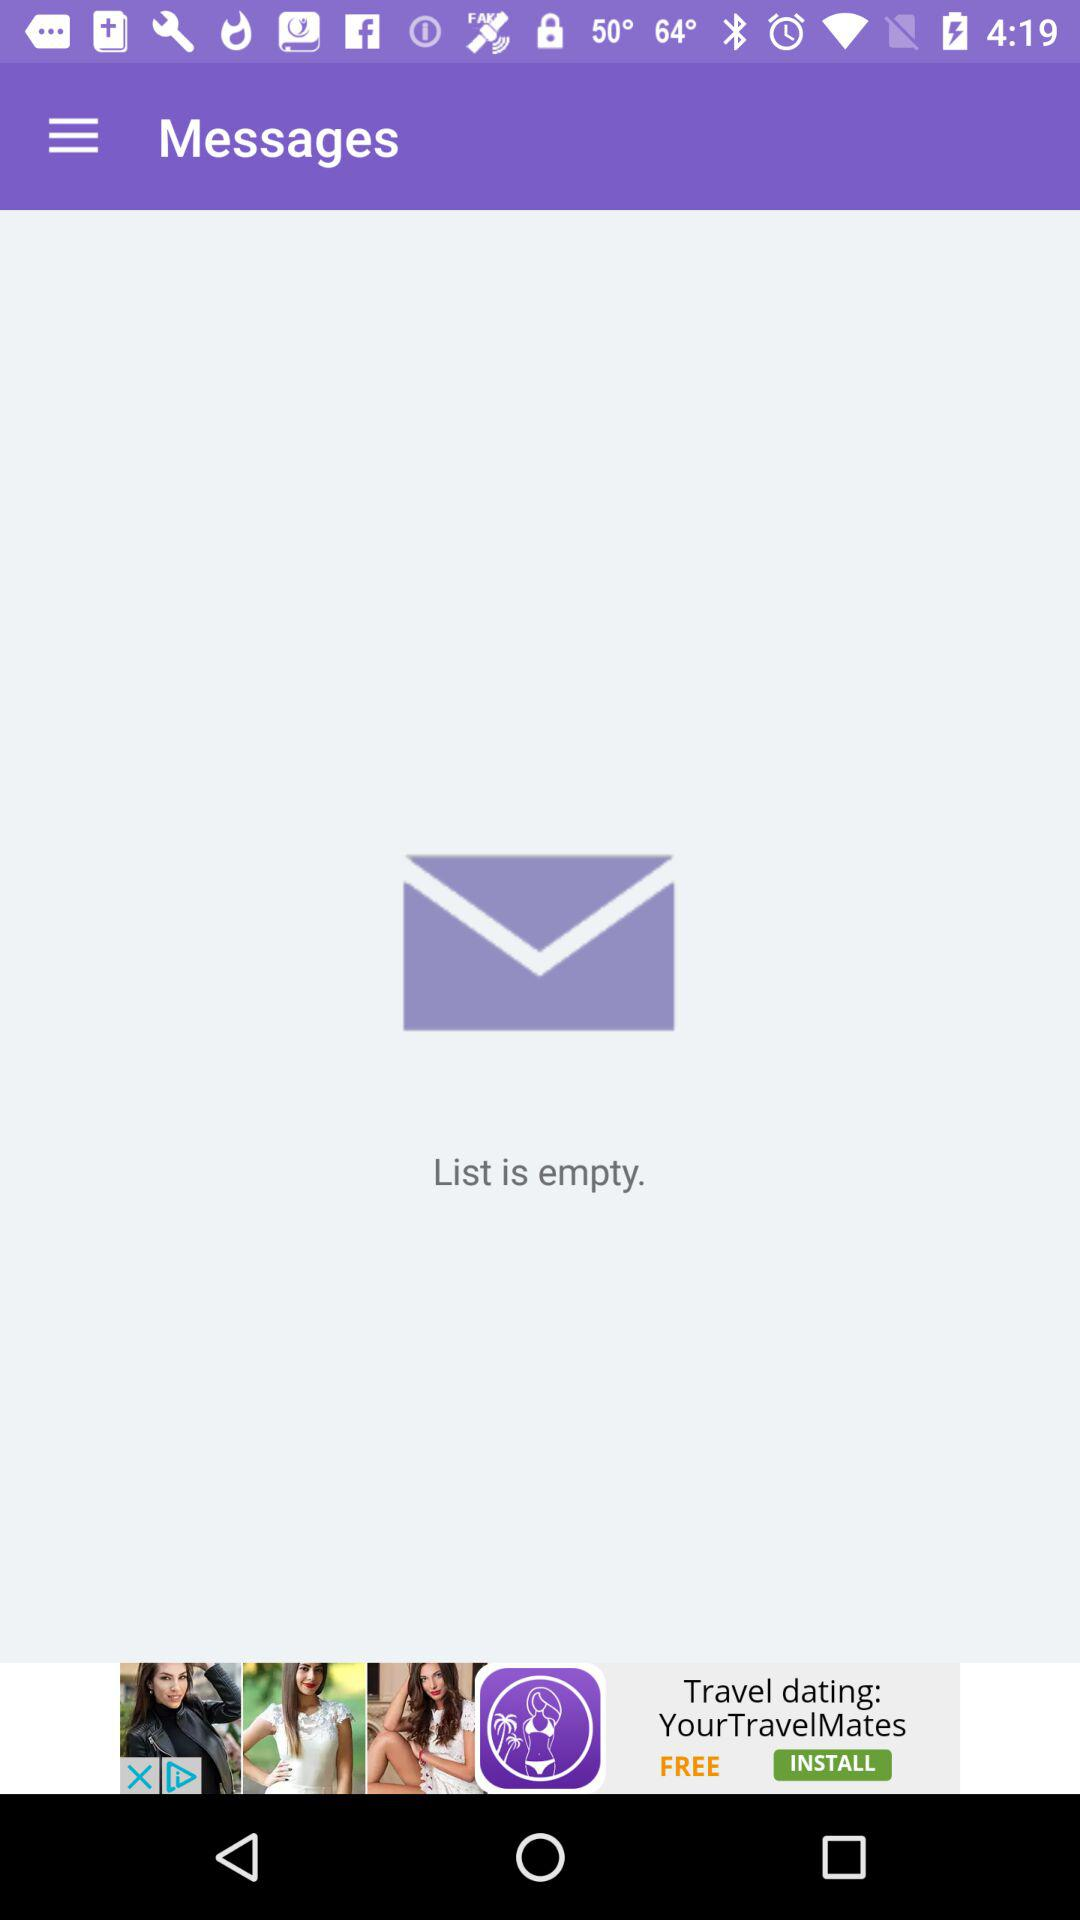How many messages are there in the list? The list is empty. 